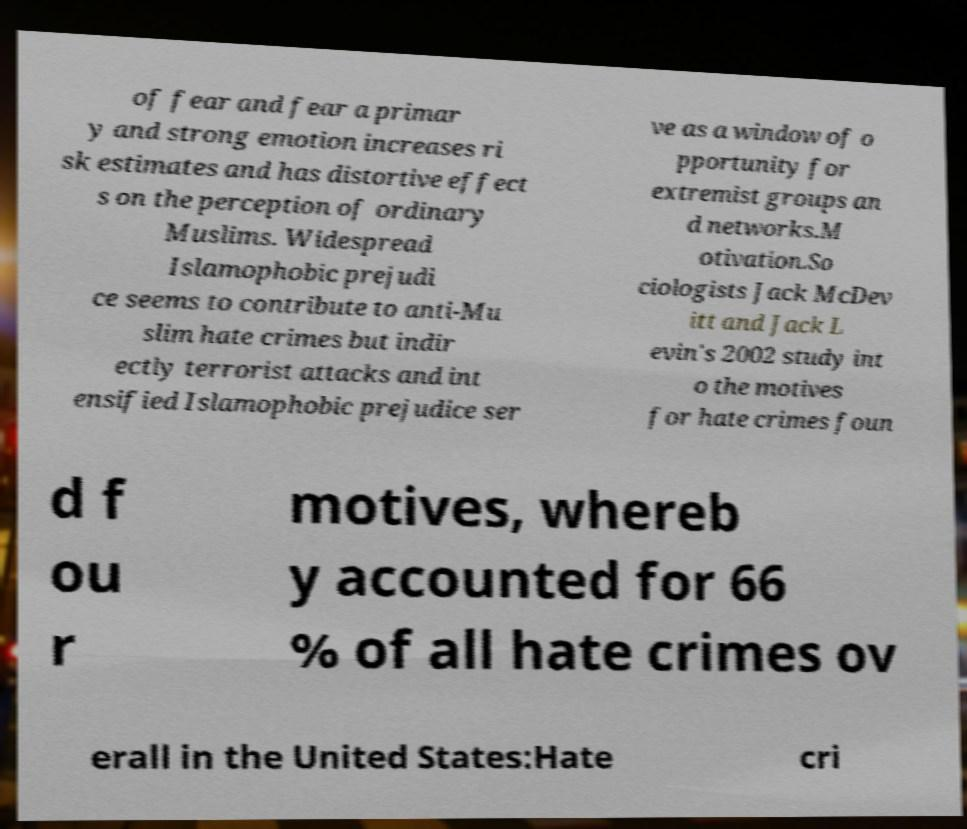I need the written content from this picture converted into text. Can you do that? of fear and fear a primar y and strong emotion increases ri sk estimates and has distortive effect s on the perception of ordinary Muslims. Widespread Islamophobic prejudi ce seems to contribute to anti-Mu slim hate crimes but indir ectly terrorist attacks and int ensified Islamophobic prejudice ser ve as a window of o pportunity for extremist groups an d networks.M otivation.So ciologists Jack McDev itt and Jack L evin's 2002 study int o the motives for hate crimes foun d f ou r motives, whereb y accounted for 66 % of all hate crimes ov erall in the United States:Hate cri 